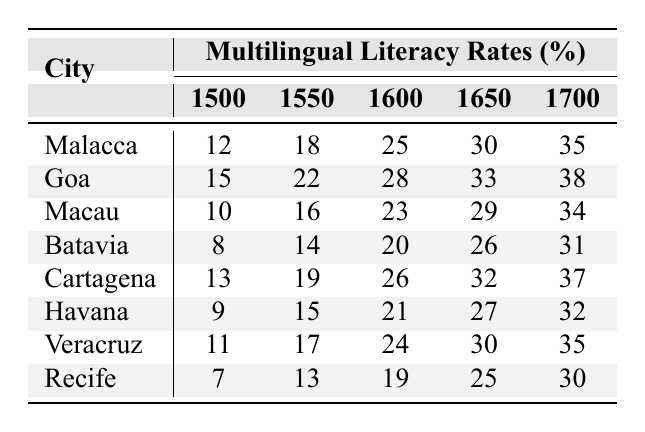What was the literacy rate in Malacca in 1700? From the table, the literacy rate for Malacca in the year 1700 is directly provided. Looking at the row for Malacca and the column for the year 1700, the rate is 35%.
Answer: 35% Which city had the highest literacy rate in 1600? To find the highest literacy rate in 1600, we compare the values in the 1600 column for all cities. The rates are: Malacca (25), Goa (28), Macau (23), Batavia (20), Cartagena (26), Havana (21), Veracruz (24), and Recife (19). The highest value is 28% for Goa.
Answer: Goa What is the difference in literacy rates between Goa in 1550 and Batavia in 1650? First, we look at the literacy rates: Goa in 1550 is 22% and Batavia in 1650 is 26%. Next, we find the difference: 26 - 22 = 4%.
Answer: 4% Was the literacy rate in Recife higher than that in Macau in 1500? The literacy rate for Recife in 1500 is 7%, and for Macau, it is 10%. Since 7% is less than 10%, the statement is false.
Answer: No What is the average literacy rate in Havana from 1500 to 1700? To find the average, we first sum the literacy rates for Havana in each year: 9 + 15 + 21 + 27 + 32 = 104. There are 5 data points, so we divide by 5: 104 / 5 = 20.8%.
Answer: 20.8% Which city experienced the largest increase in literacy rate from 1500 to 1700? We calculate the increase for each city: Malacca (35 - 12 = 23), Goa (38 - 15 = 23), Macau (34 - 10 = 24), Batavia (31 - 8 = 23), Cartagena (37 - 13 = 24), Havana (32 - 9 = 23), Veracruz (35 - 11 = 24), Recife (30 - 7 = 23). The highest increase is 24% in Macau, Cartagena, Veracruz, and Recife.
Answer: Macau, Cartagena, Veracruz, Recife What were the literacy rates in Portuguese in 1650 compared among the cities? The literacy rates in 1650 are: Malacca (30), Goa (33), Macau (29), Batavia (26), Cartagena (32), Havana (27), Veracruz (30), and Recife (25). Therefore, Goa performed best at 33%.
Answer: Goa Is it true that all cities had a literacy rate above 20% by 1700? Checking the column for the year 1700: Malacca (35), Goa (38), Macau (34), Batavia (31), Cartagena (37), Havana (32), Veracruz (35), Recife (30). All rates are above 20%. Thus, the statement is true.
Answer: Yes What city had lower literacy rates: Recife or Batavia in 1600? In 1600, Recife had a literacy rate of 19%, while Batavia had a rate of 20%. Since 19% is less than 20%, Recife had the lower rate.
Answer: Recife 